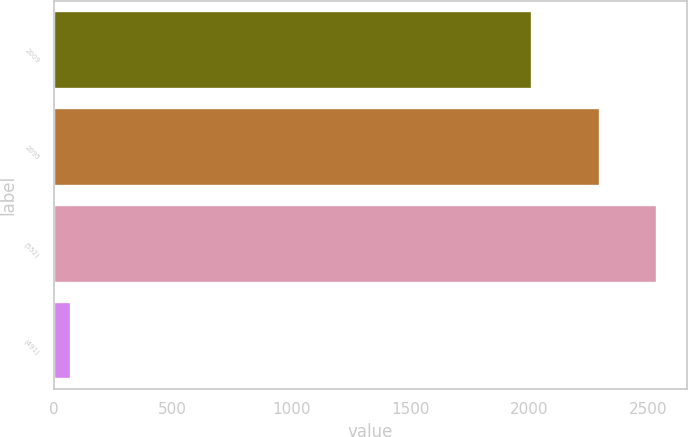<chart> <loc_0><loc_0><loc_500><loc_500><bar_chart><fcel>2009<fcel>2095<fcel>(552)<fcel>(491)<nl><fcel>2008<fcel>2294<fcel>2533.9<fcel>74<nl></chart> 